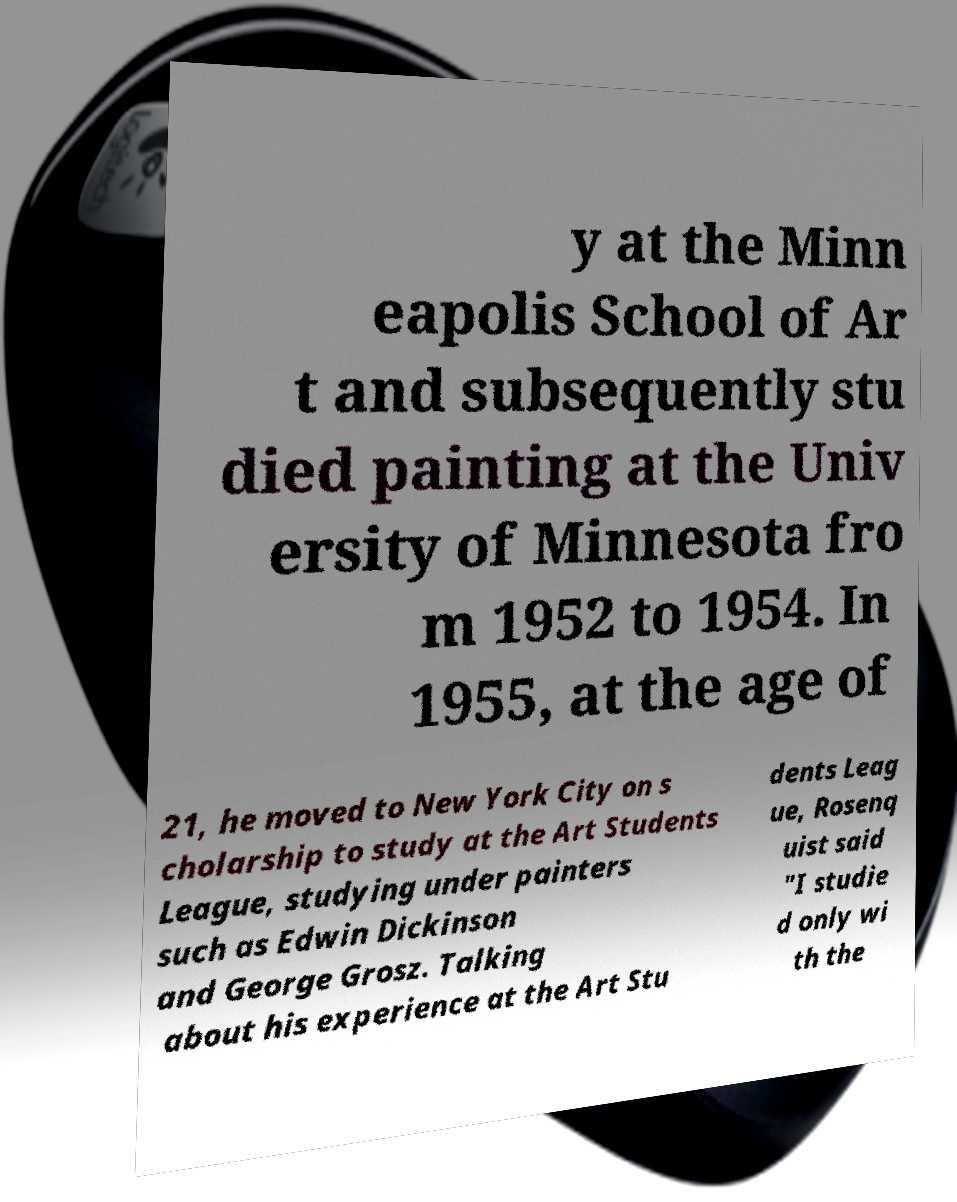Could you extract and type out the text from this image? y at the Minn eapolis School of Ar t and subsequently stu died painting at the Univ ersity of Minnesota fro m 1952 to 1954. In 1955, at the age of 21, he moved to New York City on s cholarship to study at the Art Students League, studying under painters such as Edwin Dickinson and George Grosz. Talking about his experience at the Art Stu dents Leag ue, Rosenq uist said "I studie d only wi th the 